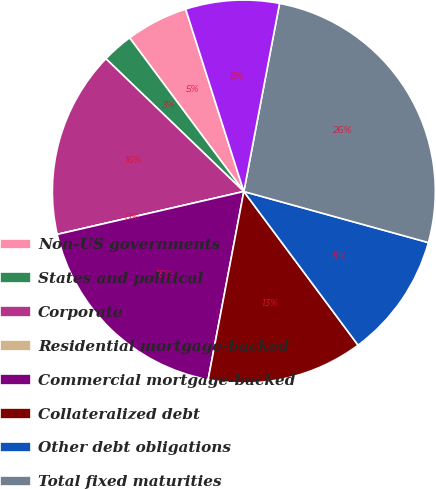<chart> <loc_0><loc_0><loc_500><loc_500><pie_chart><fcel>Non-US governments<fcel>States and political<fcel>Corporate<fcel>Residential mortgage-backed<fcel>Commercial mortgage-backed<fcel>Collateralized debt<fcel>Other debt obligations<fcel>Total fixed maturities<fcel>Total equity securities<nl><fcel>5.26%<fcel>2.63%<fcel>15.79%<fcel>0.0%<fcel>18.42%<fcel>13.16%<fcel>10.53%<fcel>26.31%<fcel>7.9%<nl></chart> 